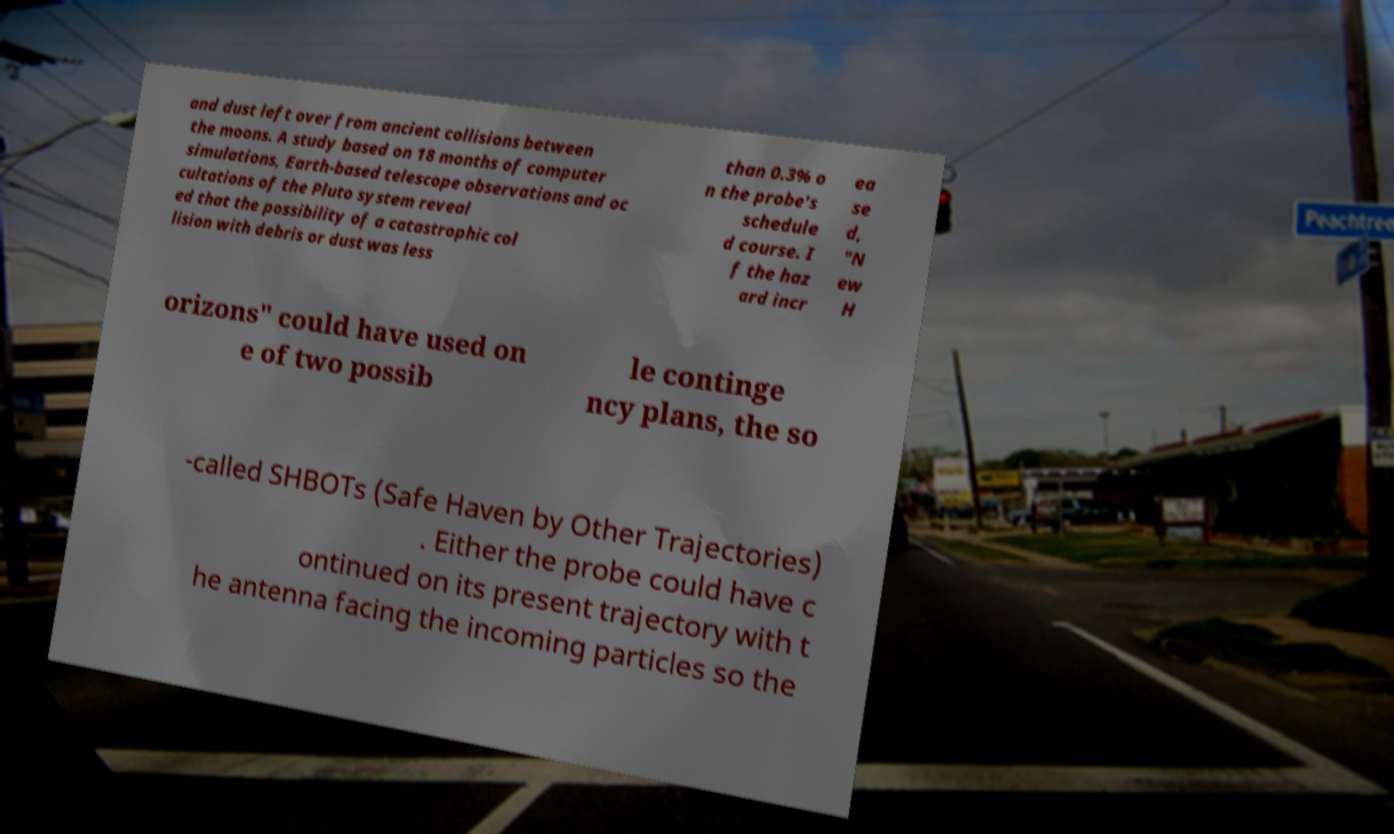Can you accurately transcribe the text from the provided image for me? and dust left over from ancient collisions between the moons. A study based on 18 months of computer simulations, Earth-based telescope observations and oc cultations of the Pluto system reveal ed that the possibility of a catastrophic col lision with debris or dust was less than 0.3% o n the probe's schedule d course. I f the haz ard incr ea se d, "N ew H orizons" could have used on e of two possib le continge ncy plans, the so -called SHBOTs (Safe Haven by Other Trajectories) . Either the probe could have c ontinued on its present trajectory with t he antenna facing the incoming particles so the 